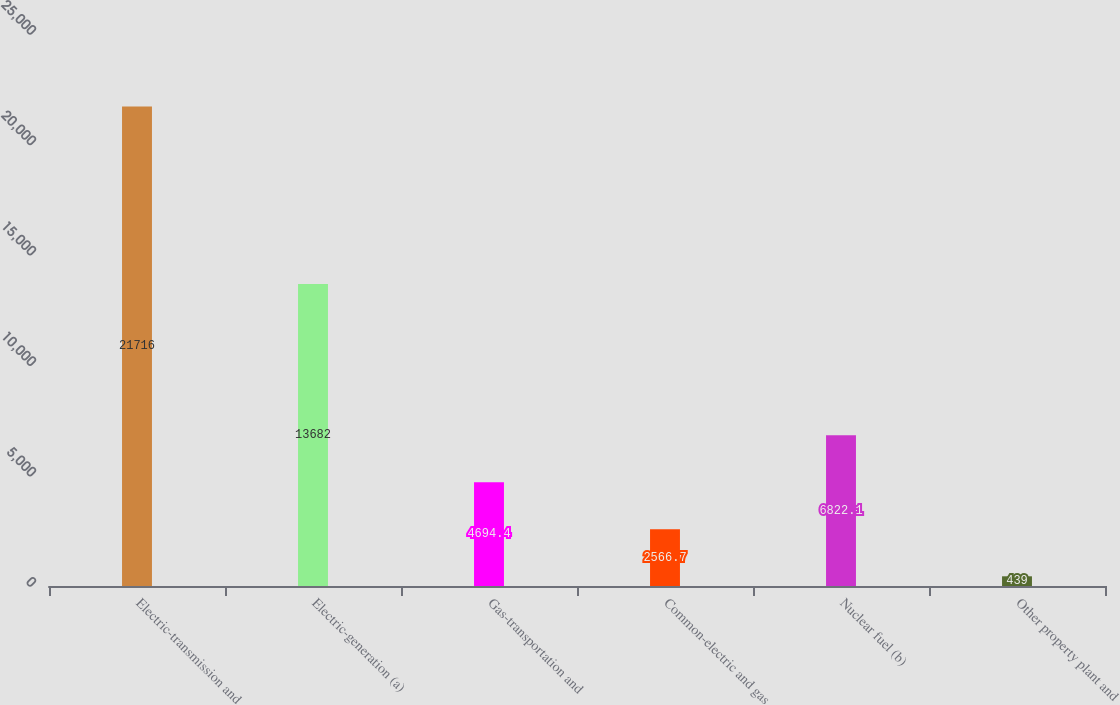Convert chart to OTSL. <chart><loc_0><loc_0><loc_500><loc_500><bar_chart><fcel>Electric-transmission and<fcel>Electric-generation (a)<fcel>Gas-transportation and<fcel>Common-electric and gas<fcel>Nuclear fuel (b)<fcel>Other property plant and<nl><fcel>21716<fcel>13682<fcel>4694.4<fcel>2566.7<fcel>6822.1<fcel>439<nl></chart> 